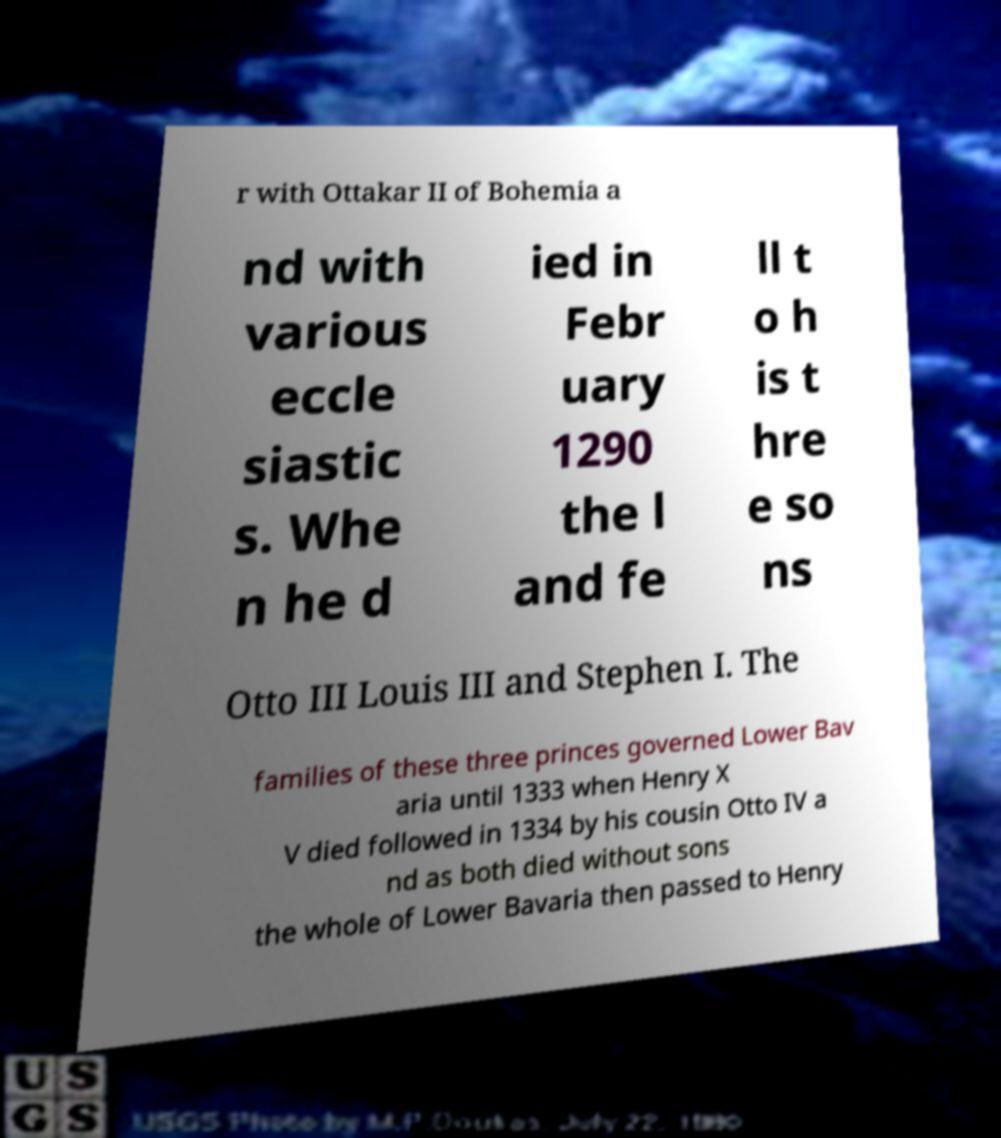Please identify and transcribe the text found in this image. r with Ottakar II of Bohemia a nd with various eccle siastic s. Whe n he d ied in Febr uary 1290 the l and fe ll t o h is t hre e so ns Otto III Louis III and Stephen I. The families of these three princes governed Lower Bav aria until 1333 when Henry X V died followed in 1334 by his cousin Otto IV a nd as both died without sons the whole of Lower Bavaria then passed to Henry 